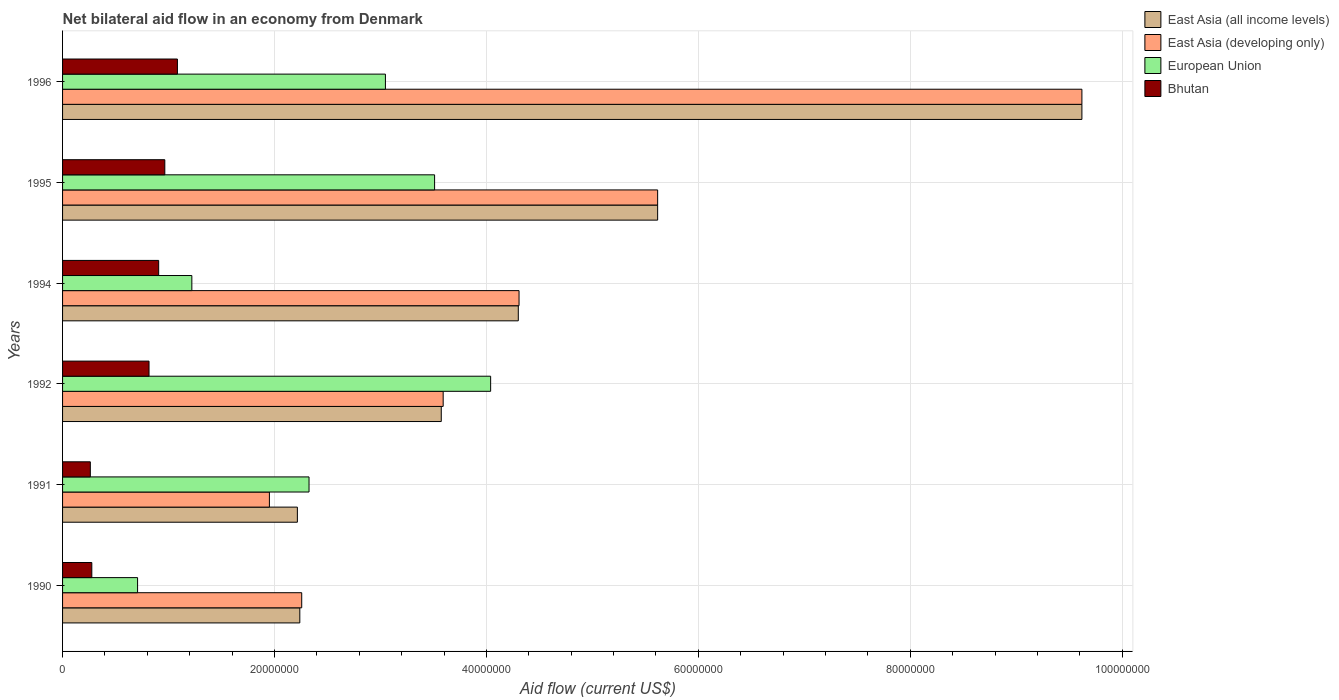How many different coloured bars are there?
Ensure brevity in your answer.  4. Are the number of bars per tick equal to the number of legend labels?
Keep it short and to the point. Yes. Are the number of bars on each tick of the Y-axis equal?
Keep it short and to the point. Yes. How many bars are there on the 2nd tick from the bottom?
Offer a terse response. 4. What is the label of the 6th group of bars from the top?
Keep it short and to the point. 1990. In how many cases, is the number of bars for a given year not equal to the number of legend labels?
Ensure brevity in your answer.  0. What is the net bilateral aid flow in Bhutan in 1992?
Your answer should be very brief. 8.16e+06. Across all years, what is the maximum net bilateral aid flow in Bhutan?
Give a very brief answer. 1.08e+07. Across all years, what is the minimum net bilateral aid flow in East Asia (all income levels)?
Give a very brief answer. 2.22e+07. In which year was the net bilateral aid flow in East Asia (developing only) maximum?
Keep it short and to the point. 1996. In which year was the net bilateral aid flow in East Asia (all income levels) minimum?
Give a very brief answer. 1991. What is the total net bilateral aid flow in European Union in the graph?
Your answer should be compact. 1.49e+08. What is the difference between the net bilateral aid flow in East Asia (all income levels) in 1991 and that in 1992?
Offer a very short reply. -1.36e+07. What is the difference between the net bilateral aid flow in East Asia (developing only) in 1992 and the net bilateral aid flow in European Union in 1995?
Your answer should be very brief. 8.10e+05. What is the average net bilateral aid flow in European Union per year?
Offer a terse response. 2.48e+07. What is the ratio of the net bilateral aid flow in European Union in 1990 to that in 1996?
Ensure brevity in your answer.  0.23. What is the difference between the highest and the second highest net bilateral aid flow in Bhutan?
Make the answer very short. 1.19e+06. What is the difference between the highest and the lowest net bilateral aid flow in Bhutan?
Offer a very short reply. 8.22e+06. In how many years, is the net bilateral aid flow in East Asia (developing only) greater than the average net bilateral aid flow in East Asia (developing only) taken over all years?
Make the answer very short. 2. Is the sum of the net bilateral aid flow in European Union in 1994 and 1995 greater than the maximum net bilateral aid flow in East Asia (all income levels) across all years?
Make the answer very short. No. Is it the case that in every year, the sum of the net bilateral aid flow in European Union and net bilateral aid flow in Bhutan is greater than the sum of net bilateral aid flow in East Asia (all income levels) and net bilateral aid flow in East Asia (developing only)?
Provide a succinct answer. No. What does the 3rd bar from the top in 1992 represents?
Offer a terse response. East Asia (developing only). How many bars are there?
Ensure brevity in your answer.  24. Are all the bars in the graph horizontal?
Make the answer very short. Yes. What is the difference between two consecutive major ticks on the X-axis?
Ensure brevity in your answer.  2.00e+07. What is the title of the graph?
Keep it short and to the point. Net bilateral aid flow in an economy from Denmark. Does "Palau" appear as one of the legend labels in the graph?
Your response must be concise. No. What is the label or title of the Y-axis?
Make the answer very short. Years. What is the Aid flow (current US$) of East Asia (all income levels) in 1990?
Give a very brief answer. 2.24e+07. What is the Aid flow (current US$) in East Asia (developing only) in 1990?
Offer a very short reply. 2.26e+07. What is the Aid flow (current US$) of European Union in 1990?
Make the answer very short. 7.08e+06. What is the Aid flow (current US$) of Bhutan in 1990?
Your answer should be very brief. 2.76e+06. What is the Aid flow (current US$) in East Asia (all income levels) in 1991?
Give a very brief answer. 2.22e+07. What is the Aid flow (current US$) in East Asia (developing only) in 1991?
Give a very brief answer. 1.95e+07. What is the Aid flow (current US$) in European Union in 1991?
Give a very brief answer. 2.33e+07. What is the Aid flow (current US$) in Bhutan in 1991?
Ensure brevity in your answer.  2.62e+06. What is the Aid flow (current US$) in East Asia (all income levels) in 1992?
Offer a terse response. 3.57e+07. What is the Aid flow (current US$) of East Asia (developing only) in 1992?
Your answer should be compact. 3.59e+07. What is the Aid flow (current US$) of European Union in 1992?
Give a very brief answer. 4.04e+07. What is the Aid flow (current US$) of Bhutan in 1992?
Offer a terse response. 8.16e+06. What is the Aid flow (current US$) in East Asia (all income levels) in 1994?
Make the answer very short. 4.30e+07. What is the Aid flow (current US$) of East Asia (developing only) in 1994?
Provide a succinct answer. 4.31e+07. What is the Aid flow (current US$) of European Union in 1994?
Provide a succinct answer. 1.22e+07. What is the Aid flow (current US$) in Bhutan in 1994?
Make the answer very short. 9.07e+06. What is the Aid flow (current US$) in East Asia (all income levels) in 1995?
Keep it short and to the point. 5.62e+07. What is the Aid flow (current US$) in East Asia (developing only) in 1995?
Give a very brief answer. 5.62e+07. What is the Aid flow (current US$) of European Union in 1995?
Your answer should be very brief. 3.51e+07. What is the Aid flow (current US$) of Bhutan in 1995?
Make the answer very short. 9.65e+06. What is the Aid flow (current US$) of East Asia (all income levels) in 1996?
Give a very brief answer. 9.62e+07. What is the Aid flow (current US$) in East Asia (developing only) in 1996?
Provide a short and direct response. 9.62e+07. What is the Aid flow (current US$) of European Union in 1996?
Keep it short and to the point. 3.05e+07. What is the Aid flow (current US$) of Bhutan in 1996?
Keep it short and to the point. 1.08e+07. Across all years, what is the maximum Aid flow (current US$) in East Asia (all income levels)?
Ensure brevity in your answer.  9.62e+07. Across all years, what is the maximum Aid flow (current US$) of East Asia (developing only)?
Offer a terse response. 9.62e+07. Across all years, what is the maximum Aid flow (current US$) of European Union?
Provide a short and direct response. 4.04e+07. Across all years, what is the maximum Aid flow (current US$) of Bhutan?
Make the answer very short. 1.08e+07. Across all years, what is the minimum Aid flow (current US$) in East Asia (all income levels)?
Give a very brief answer. 2.22e+07. Across all years, what is the minimum Aid flow (current US$) in East Asia (developing only)?
Provide a succinct answer. 1.95e+07. Across all years, what is the minimum Aid flow (current US$) in European Union?
Give a very brief answer. 7.08e+06. Across all years, what is the minimum Aid flow (current US$) of Bhutan?
Offer a very short reply. 2.62e+06. What is the total Aid flow (current US$) of East Asia (all income levels) in the graph?
Your response must be concise. 2.76e+08. What is the total Aid flow (current US$) of East Asia (developing only) in the graph?
Keep it short and to the point. 2.73e+08. What is the total Aid flow (current US$) of European Union in the graph?
Offer a terse response. 1.49e+08. What is the total Aid flow (current US$) of Bhutan in the graph?
Your answer should be very brief. 4.31e+07. What is the difference between the Aid flow (current US$) in East Asia (developing only) in 1990 and that in 1991?
Your answer should be very brief. 3.05e+06. What is the difference between the Aid flow (current US$) of European Union in 1990 and that in 1991?
Offer a terse response. -1.62e+07. What is the difference between the Aid flow (current US$) in Bhutan in 1990 and that in 1991?
Provide a short and direct response. 1.40e+05. What is the difference between the Aid flow (current US$) in East Asia (all income levels) in 1990 and that in 1992?
Provide a short and direct response. -1.34e+07. What is the difference between the Aid flow (current US$) of East Asia (developing only) in 1990 and that in 1992?
Your response must be concise. -1.34e+07. What is the difference between the Aid flow (current US$) of European Union in 1990 and that in 1992?
Provide a short and direct response. -3.33e+07. What is the difference between the Aid flow (current US$) in Bhutan in 1990 and that in 1992?
Your answer should be very brief. -5.40e+06. What is the difference between the Aid flow (current US$) in East Asia (all income levels) in 1990 and that in 1994?
Provide a short and direct response. -2.06e+07. What is the difference between the Aid flow (current US$) of East Asia (developing only) in 1990 and that in 1994?
Your response must be concise. -2.05e+07. What is the difference between the Aid flow (current US$) in European Union in 1990 and that in 1994?
Keep it short and to the point. -5.12e+06. What is the difference between the Aid flow (current US$) of Bhutan in 1990 and that in 1994?
Your response must be concise. -6.31e+06. What is the difference between the Aid flow (current US$) in East Asia (all income levels) in 1990 and that in 1995?
Provide a succinct answer. -3.38e+07. What is the difference between the Aid flow (current US$) in East Asia (developing only) in 1990 and that in 1995?
Your answer should be very brief. -3.36e+07. What is the difference between the Aid flow (current US$) in European Union in 1990 and that in 1995?
Provide a succinct answer. -2.80e+07. What is the difference between the Aid flow (current US$) of Bhutan in 1990 and that in 1995?
Your answer should be compact. -6.89e+06. What is the difference between the Aid flow (current US$) of East Asia (all income levels) in 1990 and that in 1996?
Provide a succinct answer. -7.38e+07. What is the difference between the Aid flow (current US$) in East Asia (developing only) in 1990 and that in 1996?
Your answer should be very brief. -7.36e+07. What is the difference between the Aid flow (current US$) of European Union in 1990 and that in 1996?
Your answer should be compact. -2.34e+07. What is the difference between the Aid flow (current US$) of Bhutan in 1990 and that in 1996?
Your response must be concise. -8.08e+06. What is the difference between the Aid flow (current US$) in East Asia (all income levels) in 1991 and that in 1992?
Your response must be concise. -1.36e+07. What is the difference between the Aid flow (current US$) of East Asia (developing only) in 1991 and that in 1992?
Provide a short and direct response. -1.64e+07. What is the difference between the Aid flow (current US$) in European Union in 1991 and that in 1992?
Provide a succinct answer. -1.71e+07. What is the difference between the Aid flow (current US$) of Bhutan in 1991 and that in 1992?
Provide a short and direct response. -5.54e+06. What is the difference between the Aid flow (current US$) in East Asia (all income levels) in 1991 and that in 1994?
Ensure brevity in your answer.  -2.08e+07. What is the difference between the Aid flow (current US$) in East Asia (developing only) in 1991 and that in 1994?
Make the answer very short. -2.36e+07. What is the difference between the Aid flow (current US$) of European Union in 1991 and that in 1994?
Your answer should be compact. 1.11e+07. What is the difference between the Aid flow (current US$) of Bhutan in 1991 and that in 1994?
Provide a succinct answer. -6.45e+06. What is the difference between the Aid flow (current US$) in East Asia (all income levels) in 1991 and that in 1995?
Ensure brevity in your answer.  -3.40e+07. What is the difference between the Aid flow (current US$) of East Asia (developing only) in 1991 and that in 1995?
Offer a terse response. -3.66e+07. What is the difference between the Aid flow (current US$) of European Union in 1991 and that in 1995?
Offer a terse response. -1.18e+07. What is the difference between the Aid flow (current US$) in Bhutan in 1991 and that in 1995?
Your answer should be very brief. -7.03e+06. What is the difference between the Aid flow (current US$) of East Asia (all income levels) in 1991 and that in 1996?
Give a very brief answer. -7.40e+07. What is the difference between the Aid flow (current US$) in East Asia (developing only) in 1991 and that in 1996?
Keep it short and to the point. -7.67e+07. What is the difference between the Aid flow (current US$) of European Union in 1991 and that in 1996?
Give a very brief answer. -7.21e+06. What is the difference between the Aid flow (current US$) of Bhutan in 1991 and that in 1996?
Provide a short and direct response. -8.22e+06. What is the difference between the Aid flow (current US$) in East Asia (all income levels) in 1992 and that in 1994?
Make the answer very short. -7.27e+06. What is the difference between the Aid flow (current US$) of East Asia (developing only) in 1992 and that in 1994?
Provide a short and direct response. -7.16e+06. What is the difference between the Aid flow (current US$) of European Union in 1992 and that in 1994?
Ensure brevity in your answer.  2.82e+07. What is the difference between the Aid flow (current US$) in Bhutan in 1992 and that in 1994?
Your answer should be compact. -9.10e+05. What is the difference between the Aid flow (current US$) of East Asia (all income levels) in 1992 and that in 1995?
Your answer should be very brief. -2.04e+07. What is the difference between the Aid flow (current US$) in East Asia (developing only) in 1992 and that in 1995?
Ensure brevity in your answer.  -2.02e+07. What is the difference between the Aid flow (current US$) of European Union in 1992 and that in 1995?
Keep it short and to the point. 5.29e+06. What is the difference between the Aid flow (current US$) of Bhutan in 1992 and that in 1995?
Offer a very short reply. -1.49e+06. What is the difference between the Aid flow (current US$) of East Asia (all income levels) in 1992 and that in 1996?
Provide a short and direct response. -6.05e+07. What is the difference between the Aid flow (current US$) in East Asia (developing only) in 1992 and that in 1996?
Your answer should be very brief. -6.03e+07. What is the difference between the Aid flow (current US$) in European Union in 1992 and that in 1996?
Provide a succinct answer. 9.93e+06. What is the difference between the Aid flow (current US$) in Bhutan in 1992 and that in 1996?
Your answer should be compact. -2.68e+06. What is the difference between the Aid flow (current US$) in East Asia (all income levels) in 1994 and that in 1995?
Offer a terse response. -1.32e+07. What is the difference between the Aid flow (current US$) in East Asia (developing only) in 1994 and that in 1995?
Offer a terse response. -1.31e+07. What is the difference between the Aid flow (current US$) of European Union in 1994 and that in 1995?
Keep it short and to the point. -2.29e+07. What is the difference between the Aid flow (current US$) in Bhutan in 1994 and that in 1995?
Your answer should be compact. -5.80e+05. What is the difference between the Aid flow (current US$) of East Asia (all income levels) in 1994 and that in 1996?
Your response must be concise. -5.32e+07. What is the difference between the Aid flow (current US$) in East Asia (developing only) in 1994 and that in 1996?
Keep it short and to the point. -5.31e+07. What is the difference between the Aid flow (current US$) of European Union in 1994 and that in 1996?
Ensure brevity in your answer.  -1.83e+07. What is the difference between the Aid flow (current US$) of Bhutan in 1994 and that in 1996?
Your answer should be compact. -1.77e+06. What is the difference between the Aid flow (current US$) of East Asia (all income levels) in 1995 and that in 1996?
Offer a terse response. -4.00e+07. What is the difference between the Aid flow (current US$) in East Asia (developing only) in 1995 and that in 1996?
Make the answer very short. -4.00e+07. What is the difference between the Aid flow (current US$) in European Union in 1995 and that in 1996?
Ensure brevity in your answer.  4.64e+06. What is the difference between the Aid flow (current US$) in Bhutan in 1995 and that in 1996?
Provide a succinct answer. -1.19e+06. What is the difference between the Aid flow (current US$) in East Asia (all income levels) in 1990 and the Aid flow (current US$) in East Asia (developing only) in 1991?
Your answer should be compact. 2.87e+06. What is the difference between the Aid flow (current US$) of East Asia (all income levels) in 1990 and the Aid flow (current US$) of European Union in 1991?
Keep it short and to the point. -8.70e+05. What is the difference between the Aid flow (current US$) in East Asia (all income levels) in 1990 and the Aid flow (current US$) in Bhutan in 1991?
Give a very brief answer. 1.98e+07. What is the difference between the Aid flow (current US$) of East Asia (developing only) in 1990 and the Aid flow (current US$) of European Union in 1991?
Your answer should be very brief. -6.90e+05. What is the difference between the Aid flow (current US$) in East Asia (developing only) in 1990 and the Aid flow (current US$) in Bhutan in 1991?
Your answer should be very brief. 2.00e+07. What is the difference between the Aid flow (current US$) of European Union in 1990 and the Aid flow (current US$) of Bhutan in 1991?
Your answer should be compact. 4.46e+06. What is the difference between the Aid flow (current US$) of East Asia (all income levels) in 1990 and the Aid flow (current US$) of East Asia (developing only) in 1992?
Keep it short and to the point. -1.35e+07. What is the difference between the Aid flow (current US$) in East Asia (all income levels) in 1990 and the Aid flow (current US$) in European Union in 1992?
Make the answer very short. -1.80e+07. What is the difference between the Aid flow (current US$) in East Asia (all income levels) in 1990 and the Aid flow (current US$) in Bhutan in 1992?
Give a very brief answer. 1.42e+07. What is the difference between the Aid flow (current US$) of East Asia (developing only) in 1990 and the Aid flow (current US$) of European Union in 1992?
Offer a very short reply. -1.78e+07. What is the difference between the Aid flow (current US$) of East Asia (developing only) in 1990 and the Aid flow (current US$) of Bhutan in 1992?
Offer a terse response. 1.44e+07. What is the difference between the Aid flow (current US$) in European Union in 1990 and the Aid flow (current US$) in Bhutan in 1992?
Make the answer very short. -1.08e+06. What is the difference between the Aid flow (current US$) of East Asia (all income levels) in 1990 and the Aid flow (current US$) of East Asia (developing only) in 1994?
Your answer should be compact. -2.07e+07. What is the difference between the Aid flow (current US$) of East Asia (all income levels) in 1990 and the Aid flow (current US$) of European Union in 1994?
Make the answer very short. 1.02e+07. What is the difference between the Aid flow (current US$) in East Asia (all income levels) in 1990 and the Aid flow (current US$) in Bhutan in 1994?
Offer a very short reply. 1.33e+07. What is the difference between the Aid flow (current US$) in East Asia (developing only) in 1990 and the Aid flow (current US$) in European Union in 1994?
Your answer should be compact. 1.04e+07. What is the difference between the Aid flow (current US$) of East Asia (developing only) in 1990 and the Aid flow (current US$) of Bhutan in 1994?
Your answer should be very brief. 1.35e+07. What is the difference between the Aid flow (current US$) of European Union in 1990 and the Aid flow (current US$) of Bhutan in 1994?
Offer a terse response. -1.99e+06. What is the difference between the Aid flow (current US$) in East Asia (all income levels) in 1990 and the Aid flow (current US$) in East Asia (developing only) in 1995?
Offer a very short reply. -3.38e+07. What is the difference between the Aid flow (current US$) of East Asia (all income levels) in 1990 and the Aid flow (current US$) of European Union in 1995?
Provide a succinct answer. -1.27e+07. What is the difference between the Aid flow (current US$) in East Asia (all income levels) in 1990 and the Aid flow (current US$) in Bhutan in 1995?
Make the answer very short. 1.27e+07. What is the difference between the Aid flow (current US$) in East Asia (developing only) in 1990 and the Aid flow (current US$) in European Union in 1995?
Keep it short and to the point. -1.25e+07. What is the difference between the Aid flow (current US$) in East Asia (developing only) in 1990 and the Aid flow (current US$) in Bhutan in 1995?
Keep it short and to the point. 1.29e+07. What is the difference between the Aid flow (current US$) in European Union in 1990 and the Aid flow (current US$) in Bhutan in 1995?
Ensure brevity in your answer.  -2.57e+06. What is the difference between the Aid flow (current US$) in East Asia (all income levels) in 1990 and the Aid flow (current US$) in East Asia (developing only) in 1996?
Offer a very short reply. -7.38e+07. What is the difference between the Aid flow (current US$) of East Asia (all income levels) in 1990 and the Aid flow (current US$) of European Union in 1996?
Ensure brevity in your answer.  -8.08e+06. What is the difference between the Aid flow (current US$) in East Asia (all income levels) in 1990 and the Aid flow (current US$) in Bhutan in 1996?
Provide a succinct answer. 1.16e+07. What is the difference between the Aid flow (current US$) in East Asia (developing only) in 1990 and the Aid flow (current US$) in European Union in 1996?
Make the answer very short. -7.90e+06. What is the difference between the Aid flow (current US$) of East Asia (developing only) in 1990 and the Aid flow (current US$) of Bhutan in 1996?
Provide a succinct answer. 1.17e+07. What is the difference between the Aid flow (current US$) of European Union in 1990 and the Aid flow (current US$) of Bhutan in 1996?
Ensure brevity in your answer.  -3.76e+06. What is the difference between the Aid flow (current US$) in East Asia (all income levels) in 1991 and the Aid flow (current US$) in East Asia (developing only) in 1992?
Offer a terse response. -1.38e+07. What is the difference between the Aid flow (current US$) in East Asia (all income levels) in 1991 and the Aid flow (current US$) in European Union in 1992?
Offer a very short reply. -1.82e+07. What is the difference between the Aid flow (current US$) in East Asia (all income levels) in 1991 and the Aid flow (current US$) in Bhutan in 1992?
Offer a terse response. 1.40e+07. What is the difference between the Aid flow (current US$) of East Asia (developing only) in 1991 and the Aid flow (current US$) of European Union in 1992?
Your response must be concise. -2.09e+07. What is the difference between the Aid flow (current US$) in East Asia (developing only) in 1991 and the Aid flow (current US$) in Bhutan in 1992?
Keep it short and to the point. 1.14e+07. What is the difference between the Aid flow (current US$) of European Union in 1991 and the Aid flow (current US$) of Bhutan in 1992?
Offer a terse response. 1.51e+07. What is the difference between the Aid flow (current US$) in East Asia (all income levels) in 1991 and the Aid flow (current US$) in East Asia (developing only) in 1994?
Your response must be concise. -2.09e+07. What is the difference between the Aid flow (current US$) in East Asia (all income levels) in 1991 and the Aid flow (current US$) in European Union in 1994?
Your answer should be compact. 9.96e+06. What is the difference between the Aid flow (current US$) in East Asia (all income levels) in 1991 and the Aid flow (current US$) in Bhutan in 1994?
Your answer should be very brief. 1.31e+07. What is the difference between the Aid flow (current US$) of East Asia (developing only) in 1991 and the Aid flow (current US$) of European Union in 1994?
Provide a succinct answer. 7.32e+06. What is the difference between the Aid flow (current US$) in East Asia (developing only) in 1991 and the Aid flow (current US$) in Bhutan in 1994?
Your answer should be very brief. 1.04e+07. What is the difference between the Aid flow (current US$) of European Union in 1991 and the Aid flow (current US$) of Bhutan in 1994?
Your answer should be very brief. 1.42e+07. What is the difference between the Aid flow (current US$) in East Asia (all income levels) in 1991 and the Aid flow (current US$) in East Asia (developing only) in 1995?
Give a very brief answer. -3.40e+07. What is the difference between the Aid flow (current US$) in East Asia (all income levels) in 1991 and the Aid flow (current US$) in European Union in 1995?
Provide a succinct answer. -1.30e+07. What is the difference between the Aid flow (current US$) of East Asia (all income levels) in 1991 and the Aid flow (current US$) of Bhutan in 1995?
Keep it short and to the point. 1.25e+07. What is the difference between the Aid flow (current US$) of East Asia (developing only) in 1991 and the Aid flow (current US$) of European Union in 1995?
Your answer should be compact. -1.56e+07. What is the difference between the Aid flow (current US$) in East Asia (developing only) in 1991 and the Aid flow (current US$) in Bhutan in 1995?
Make the answer very short. 9.87e+06. What is the difference between the Aid flow (current US$) of European Union in 1991 and the Aid flow (current US$) of Bhutan in 1995?
Your answer should be very brief. 1.36e+07. What is the difference between the Aid flow (current US$) of East Asia (all income levels) in 1991 and the Aid flow (current US$) of East Asia (developing only) in 1996?
Offer a very short reply. -7.40e+07. What is the difference between the Aid flow (current US$) in East Asia (all income levels) in 1991 and the Aid flow (current US$) in European Union in 1996?
Ensure brevity in your answer.  -8.31e+06. What is the difference between the Aid flow (current US$) of East Asia (all income levels) in 1991 and the Aid flow (current US$) of Bhutan in 1996?
Your answer should be compact. 1.13e+07. What is the difference between the Aid flow (current US$) of East Asia (developing only) in 1991 and the Aid flow (current US$) of European Union in 1996?
Give a very brief answer. -1.10e+07. What is the difference between the Aid flow (current US$) of East Asia (developing only) in 1991 and the Aid flow (current US$) of Bhutan in 1996?
Offer a terse response. 8.68e+06. What is the difference between the Aid flow (current US$) of European Union in 1991 and the Aid flow (current US$) of Bhutan in 1996?
Ensure brevity in your answer.  1.24e+07. What is the difference between the Aid flow (current US$) in East Asia (all income levels) in 1992 and the Aid flow (current US$) in East Asia (developing only) in 1994?
Your answer should be compact. -7.34e+06. What is the difference between the Aid flow (current US$) in East Asia (all income levels) in 1992 and the Aid flow (current US$) in European Union in 1994?
Ensure brevity in your answer.  2.35e+07. What is the difference between the Aid flow (current US$) of East Asia (all income levels) in 1992 and the Aid flow (current US$) of Bhutan in 1994?
Provide a succinct answer. 2.67e+07. What is the difference between the Aid flow (current US$) in East Asia (developing only) in 1992 and the Aid flow (current US$) in European Union in 1994?
Your answer should be compact. 2.37e+07. What is the difference between the Aid flow (current US$) in East Asia (developing only) in 1992 and the Aid flow (current US$) in Bhutan in 1994?
Your answer should be compact. 2.68e+07. What is the difference between the Aid flow (current US$) of European Union in 1992 and the Aid flow (current US$) of Bhutan in 1994?
Ensure brevity in your answer.  3.13e+07. What is the difference between the Aid flow (current US$) in East Asia (all income levels) in 1992 and the Aid flow (current US$) in East Asia (developing only) in 1995?
Your answer should be very brief. -2.04e+07. What is the difference between the Aid flow (current US$) of East Asia (all income levels) in 1992 and the Aid flow (current US$) of European Union in 1995?
Provide a short and direct response. 6.30e+05. What is the difference between the Aid flow (current US$) in East Asia (all income levels) in 1992 and the Aid flow (current US$) in Bhutan in 1995?
Provide a short and direct response. 2.61e+07. What is the difference between the Aid flow (current US$) in East Asia (developing only) in 1992 and the Aid flow (current US$) in European Union in 1995?
Your answer should be compact. 8.10e+05. What is the difference between the Aid flow (current US$) in East Asia (developing only) in 1992 and the Aid flow (current US$) in Bhutan in 1995?
Ensure brevity in your answer.  2.63e+07. What is the difference between the Aid flow (current US$) in European Union in 1992 and the Aid flow (current US$) in Bhutan in 1995?
Your response must be concise. 3.08e+07. What is the difference between the Aid flow (current US$) of East Asia (all income levels) in 1992 and the Aid flow (current US$) of East Asia (developing only) in 1996?
Offer a terse response. -6.05e+07. What is the difference between the Aid flow (current US$) of East Asia (all income levels) in 1992 and the Aid flow (current US$) of European Union in 1996?
Provide a succinct answer. 5.27e+06. What is the difference between the Aid flow (current US$) in East Asia (all income levels) in 1992 and the Aid flow (current US$) in Bhutan in 1996?
Offer a terse response. 2.49e+07. What is the difference between the Aid flow (current US$) in East Asia (developing only) in 1992 and the Aid flow (current US$) in European Union in 1996?
Your answer should be compact. 5.45e+06. What is the difference between the Aid flow (current US$) in East Asia (developing only) in 1992 and the Aid flow (current US$) in Bhutan in 1996?
Make the answer very short. 2.51e+07. What is the difference between the Aid flow (current US$) of European Union in 1992 and the Aid flow (current US$) of Bhutan in 1996?
Your answer should be very brief. 2.96e+07. What is the difference between the Aid flow (current US$) of East Asia (all income levels) in 1994 and the Aid flow (current US$) of East Asia (developing only) in 1995?
Your answer should be very brief. -1.32e+07. What is the difference between the Aid flow (current US$) in East Asia (all income levels) in 1994 and the Aid flow (current US$) in European Union in 1995?
Your answer should be very brief. 7.90e+06. What is the difference between the Aid flow (current US$) of East Asia (all income levels) in 1994 and the Aid flow (current US$) of Bhutan in 1995?
Offer a terse response. 3.34e+07. What is the difference between the Aid flow (current US$) of East Asia (developing only) in 1994 and the Aid flow (current US$) of European Union in 1995?
Offer a terse response. 7.97e+06. What is the difference between the Aid flow (current US$) in East Asia (developing only) in 1994 and the Aid flow (current US$) in Bhutan in 1995?
Make the answer very short. 3.34e+07. What is the difference between the Aid flow (current US$) in European Union in 1994 and the Aid flow (current US$) in Bhutan in 1995?
Your response must be concise. 2.55e+06. What is the difference between the Aid flow (current US$) of East Asia (all income levels) in 1994 and the Aid flow (current US$) of East Asia (developing only) in 1996?
Keep it short and to the point. -5.32e+07. What is the difference between the Aid flow (current US$) of East Asia (all income levels) in 1994 and the Aid flow (current US$) of European Union in 1996?
Offer a very short reply. 1.25e+07. What is the difference between the Aid flow (current US$) of East Asia (all income levels) in 1994 and the Aid flow (current US$) of Bhutan in 1996?
Ensure brevity in your answer.  3.22e+07. What is the difference between the Aid flow (current US$) in East Asia (developing only) in 1994 and the Aid flow (current US$) in European Union in 1996?
Provide a succinct answer. 1.26e+07. What is the difference between the Aid flow (current US$) in East Asia (developing only) in 1994 and the Aid flow (current US$) in Bhutan in 1996?
Ensure brevity in your answer.  3.22e+07. What is the difference between the Aid flow (current US$) of European Union in 1994 and the Aid flow (current US$) of Bhutan in 1996?
Give a very brief answer. 1.36e+06. What is the difference between the Aid flow (current US$) of East Asia (all income levels) in 1995 and the Aid flow (current US$) of East Asia (developing only) in 1996?
Ensure brevity in your answer.  -4.00e+07. What is the difference between the Aid flow (current US$) of East Asia (all income levels) in 1995 and the Aid flow (current US$) of European Union in 1996?
Your response must be concise. 2.57e+07. What is the difference between the Aid flow (current US$) in East Asia (all income levels) in 1995 and the Aid flow (current US$) in Bhutan in 1996?
Ensure brevity in your answer.  4.53e+07. What is the difference between the Aid flow (current US$) in East Asia (developing only) in 1995 and the Aid flow (current US$) in European Union in 1996?
Make the answer very short. 2.57e+07. What is the difference between the Aid flow (current US$) of East Asia (developing only) in 1995 and the Aid flow (current US$) of Bhutan in 1996?
Your answer should be compact. 4.53e+07. What is the difference between the Aid flow (current US$) in European Union in 1995 and the Aid flow (current US$) in Bhutan in 1996?
Ensure brevity in your answer.  2.43e+07. What is the average Aid flow (current US$) in East Asia (all income levels) per year?
Make the answer very short. 4.59e+07. What is the average Aid flow (current US$) of East Asia (developing only) per year?
Your response must be concise. 4.56e+07. What is the average Aid flow (current US$) of European Union per year?
Offer a terse response. 2.48e+07. What is the average Aid flow (current US$) of Bhutan per year?
Keep it short and to the point. 7.18e+06. In the year 1990, what is the difference between the Aid flow (current US$) in East Asia (all income levels) and Aid flow (current US$) in European Union?
Your answer should be compact. 1.53e+07. In the year 1990, what is the difference between the Aid flow (current US$) in East Asia (all income levels) and Aid flow (current US$) in Bhutan?
Offer a very short reply. 1.96e+07. In the year 1990, what is the difference between the Aid flow (current US$) in East Asia (developing only) and Aid flow (current US$) in European Union?
Offer a very short reply. 1.55e+07. In the year 1990, what is the difference between the Aid flow (current US$) in East Asia (developing only) and Aid flow (current US$) in Bhutan?
Offer a terse response. 1.98e+07. In the year 1990, what is the difference between the Aid flow (current US$) in European Union and Aid flow (current US$) in Bhutan?
Your answer should be very brief. 4.32e+06. In the year 1991, what is the difference between the Aid flow (current US$) of East Asia (all income levels) and Aid flow (current US$) of East Asia (developing only)?
Your answer should be very brief. 2.64e+06. In the year 1991, what is the difference between the Aid flow (current US$) in East Asia (all income levels) and Aid flow (current US$) in European Union?
Offer a very short reply. -1.10e+06. In the year 1991, what is the difference between the Aid flow (current US$) of East Asia (all income levels) and Aid flow (current US$) of Bhutan?
Provide a succinct answer. 1.95e+07. In the year 1991, what is the difference between the Aid flow (current US$) in East Asia (developing only) and Aid flow (current US$) in European Union?
Offer a terse response. -3.74e+06. In the year 1991, what is the difference between the Aid flow (current US$) in East Asia (developing only) and Aid flow (current US$) in Bhutan?
Provide a succinct answer. 1.69e+07. In the year 1991, what is the difference between the Aid flow (current US$) in European Union and Aid flow (current US$) in Bhutan?
Your answer should be very brief. 2.06e+07. In the year 1992, what is the difference between the Aid flow (current US$) of East Asia (all income levels) and Aid flow (current US$) of European Union?
Offer a very short reply. -4.66e+06. In the year 1992, what is the difference between the Aid flow (current US$) in East Asia (all income levels) and Aid flow (current US$) in Bhutan?
Make the answer very short. 2.76e+07. In the year 1992, what is the difference between the Aid flow (current US$) of East Asia (developing only) and Aid flow (current US$) of European Union?
Keep it short and to the point. -4.48e+06. In the year 1992, what is the difference between the Aid flow (current US$) of East Asia (developing only) and Aid flow (current US$) of Bhutan?
Your answer should be very brief. 2.78e+07. In the year 1992, what is the difference between the Aid flow (current US$) in European Union and Aid flow (current US$) in Bhutan?
Provide a succinct answer. 3.22e+07. In the year 1994, what is the difference between the Aid flow (current US$) in East Asia (all income levels) and Aid flow (current US$) in East Asia (developing only)?
Ensure brevity in your answer.  -7.00e+04. In the year 1994, what is the difference between the Aid flow (current US$) of East Asia (all income levels) and Aid flow (current US$) of European Union?
Make the answer very short. 3.08e+07. In the year 1994, what is the difference between the Aid flow (current US$) in East Asia (all income levels) and Aid flow (current US$) in Bhutan?
Make the answer very short. 3.39e+07. In the year 1994, what is the difference between the Aid flow (current US$) in East Asia (developing only) and Aid flow (current US$) in European Union?
Your answer should be compact. 3.09e+07. In the year 1994, what is the difference between the Aid flow (current US$) of East Asia (developing only) and Aid flow (current US$) of Bhutan?
Offer a terse response. 3.40e+07. In the year 1994, what is the difference between the Aid flow (current US$) in European Union and Aid flow (current US$) in Bhutan?
Offer a terse response. 3.13e+06. In the year 1995, what is the difference between the Aid flow (current US$) in East Asia (all income levels) and Aid flow (current US$) in European Union?
Your response must be concise. 2.10e+07. In the year 1995, what is the difference between the Aid flow (current US$) of East Asia (all income levels) and Aid flow (current US$) of Bhutan?
Your answer should be compact. 4.65e+07. In the year 1995, what is the difference between the Aid flow (current US$) of East Asia (developing only) and Aid flow (current US$) of European Union?
Your answer should be very brief. 2.10e+07. In the year 1995, what is the difference between the Aid flow (current US$) of East Asia (developing only) and Aid flow (current US$) of Bhutan?
Provide a succinct answer. 4.65e+07. In the year 1995, what is the difference between the Aid flow (current US$) in European Union and Aid flow (current US$) in Bhutan?
Provide a short and direct response. 2.55e+07. In the year 1996, what is the difference between the Aid flow (current US$) of East Asia (all income levels) and Aid flow (current US$) of East Asia (developing only)?
Your answer should be compact. 0. In the year 1996, what is the difference between the Aid flow (current US$) in East Asia (all income levels) and Aid flow (current US$) in European Union?
Give a very brief answer. 6.57e+07. In the year 1996, what is the difference between the Aid flow (current US$) of East Asia (all income levels) and Aid flow (current US$) of Bhutan?
Offer a terse response. 8.54e+07. In the year 1996, what is the difference between the Aid flow (current US$) of East Asia (developing only) and Aid flow (current US$) of European Union?
Provide a succinct answer. 6.57e+07. In the year 1996, what is the difference between the Aid flow (current US$) of East Asia (developing only) and Aid flow (current US$) of Bhutan?
Your response must be concise. 8.54e+07. In the year 1996, what is the difference between the Aid flow (current US$) in European Union and Aid flow (current US$) in Bhutan?
Your answer should be very brief. 1.96e+07. What is the ratio of the Aid flow (current US$) in East Asia (all income levels) in 1990 to that in 1991?
Provide a succinct answer. 1.01. What is the ratio of the Aid flow (current US$) in East Asia (developing only) in 1990 to that in 1991?
Provide a succinct answer. 1.16. What is the ratio of the Aid flow (current US$) of European Union in 1990 to that in 1991?
Your answer should be very brief. 0.3. What is the ratio of the Aid flow (current US$) in Bhutan in 1990 to that in 1991?
Ensure brevity in your answer.  1.05. What is the ratio of the Aid flow (current US$) of East Asia (all income levels) in 1990 to that in 1992?
Offer a very short reply. 0.63. What is the ratio of the Aid flow (current US$) of East Asia (developing only) in 1990 to that in 1992?
Offer a very short reply. 0.63. What is the ratio of the Aid flow (current US$) of European Union in 1990 to that in 1992?
Your answer should be very brief. 0.18. What is the ratio of the Aid flow (current US$) of Bhutan in 1990 to that in 1992?
Make the answer very short. 0.34. What is the ratio of the Aid flow (current US$) of East Asia (all income levels) in 1990 to that in 1994?
Offer a terse response. 0.52. What is the ratio of the Aid flow (current US$) of East Asia (developing only) in 1990 to that in 1994?
Keep it short and to the point. 0.52. What is the ratio of the Aid flow (current US$) in European Union in 1990 to that in 1994?
Your response must be concise. 0.58. What is the ratio of the Aid flow (current US$) of Bhutan in 1990 to that in 1994?
Provide a short and direct response. 0.3. What is the ratio of the Aid flow (current US$) in East Asia (all income levels) in 1990 to that in 1995?
Offer a terse response. 0.4. What is the ratio of the Aid flow (current US$) in East Asia (developing only) in 1990 to that in 1995?
Provide a short and direct response. 0.4. What is the ratio of the Aid flow (current US$) of European Union in 1990 to that in 1995?
Provide a succinct answer. 0.2. What is the ratio of the Aid flow (current US$) of Bhutan in 1990 to that in 1995?
Provide a succinct answer. 0.29. What is the ratio of the Aid flow (current US$) in East Asia (all income levels) in 1990 to that in 1996?
Offer a terse response. 0.23. What is the ratio of the Aid flow (current US$) of East Asia (developing only) in 1990 to that in 1996?
Give a very brief answer. 0.23. What is the ratio of the Aid flow (current US$) in European Union in 1990 to that in 1996?
Offer a very short reply. 0.23. What is the ratio of the Aid flow (current US$) in Bhutan in 1990 to that in 1996?
Your response must be concise. 0.25. What is the ratio of the Aid flow (current US$) in East Asia (all income levels) in 1991 to that in 1992?
Your response must be concise. 0.62. What is the ratio of the Aid flow (current US$) of East Asia (developing only) in 1991 to that in 1992?
Make the answer very short. 0.54. What is the ratio of the Aid flow (current US$) in European Union in 1991 to that in 1992?
Offer a terse response. 0.58. What is the ratio of the Aid flow (current US$) of Bhutan in 1991 to that in 1992?
Your response must be concise. 0.32. What is the ratio of the Aid flow (current US$) of East Asia (all income levels) in 1991 to that in 1994?
Your response must be concise. 0.52. What is the ratio of the Aid flow (current US$) of East Asia (developing only) in 1991 to that in 1994?
Your answer should be compact. 0.45. What is the ratio of the Aid flow (current US$) of European Union in 1991 to that in 1994?
Give a very brief answer. 1.91. What is the ratio of the Aid flow (current US$) in Bhutan in 1991 to that in 1994?
Your response must be concise. 0.29. What is the ratio of the Aid flow (current US$) of East Asia (all income levels) in 1991 to that in 1995?
Your answer should be compact. 0.39. What is the ratio of the Aid flow (current US$) in East Asia (developing only) in 1991 to that in 1995?
Offer a very short reply. 0.35. What is the ratio of the Aid flow (current US$) of European Union in 1991 to that in 1995?
Ensure brevity in your answer.  0.66. What is the ratio of the Aid flow (current US$) in Bhutan in 1991 to that in 1995?
Ensure brevity in your answer.  0.27. What is the ratio of the Aid flow (current US$) in East Asia (all income levels) in 1991 to that in 1996?
Offer a very short reply. 0.23. What is the ratio of the Aid flow (current US$) in East Asia (developing only) in 1991 to that in 1996?
Give a very brief answer. 0.2. What is the ratio of the Aid flow (current US$) in European Union in 1991 to that in 1996?
Offer a terse response. 0.76. What is the ratio of the Aid flow (current US$) of Bhutan in 1991 to that in 1996?
Keep it short and to the point. 0.24. What is the ratio of the Aid flow (current US$) in East Asia (all income levels) in 1992 to that in 1994?
Make the answer very short. 0.83. What is the ratio of the Aid flow (current US$) in East Asia (developing only) in 1992 to that in 1994?
Keep it short and to the point. 0.83. What is the ratio of the Aid flow (current US$) in European Union in 1992 to that in 1994?
Keep it short and to the point. 3.31. What is the ratio of the Aid flow (current US$) of Bhutan in 1992 to that in 1994?
Provide a succinct answer. 0.9. What is the ratio of the Aid flow (current US$) in East Asia (all income levels) in 1992 to that in 1995?
Your answer should be compact. 0.64. What is the ratio of the Aid flow (current US$) of East Asia (developing only) in 1992 to that in 1995?
Keep it short and to the point. 0.64. What is the ratio of the Aid flow (current US$) in European Union in 1992 to that in 1995?
Your answer should be compact. 1.15. What is the ratio of the Aid flow (current US$) in Bhutan in 1992 to that in 1995?
Make the answer very short. 0.85. What is the ratio of the Aid flow (current US$) in East Asia (all income levels) in 1992 to that in 1996?
Provide a short and direct response. 0.37. What is the ratio of the Aid flow (current US$) of East Asia (developing only) in 1992 to that in 1996?
Your answer should be compact. 0.37. What is the ratio of the Aid flow (current US$) in European Union in 1992 to that in 1996?
Offer a terse response. 1.33. What is the ratio of the Aid flow (current US$) in Bhutan in 1992 to that in 1996?
Offer a terse response. 0.75. What is the ratio of the Aid flow (current US$) of East Asia (all income levels) in 1994 to that in 1995?
Your response must be concise. 0.77. What is the ratio of the Aid flow (current US$) of East Asia (developing only) in 1994 to that in 1995?
Offer a terse response. 0.77. What is the ratio of the Aid flow (current US$) in European Union in 1994 to that in 1995?
Ensure brevity in your answer.  0.35. What is the ratio of the Aid flow (current US$) of Bhutan in 1994 to that in 1995?
Your response must be concise. 0.94. What is the ratio of the Aid flow (current US$) of East Asia (all income levels) in 1994 to that in 1996?
Your response must be concise. 0.45. What is the ratio of the Aid flow (current US$) of East Asia (developing only) in 1994 to that in 1996?
Make the answer very short. 0.45. What is the ratio of the Aid flow (current US$) of European Union in 1994 to that in 1996?
Make the answer very short. 0.4. What is the ratio of the Aid flow (current US$) in Bhutan in 1994 to that in 1996?
Ensure brevity in your answer.  0.84. What is the ratio of the Aid flow (current US$) of East Asia (all income levels) in 1995 to that in 1996?
Your answer should be compact. 0.58. What is the ratio of the Aid flow (current US$) in East Asia (developing only) in 1995 to that in 1996?
Offer a terse response. 0.58. What is the ratio of the Aid flow (current US$) of European Union in 1995 to that in 1996?
Give a very brief answer. 1.15. What is the ratio of the Aid flow (current US$) in Bhutan in 1995 to that in 1996?
Your response must be concise. 0.89. What is the difference between the highest and the second highest Aid flow (current US$) in East Asia (all income levels)?
Give a very brief answer. 4.00e+07. What is the difference between the highest and the second highest Aid flow (current US$) of East Asia (developing only)?
Your answer should be very brief. 4.00e+07. What is the difference between the highest and the second highest Aid flow (current US$) in European Union?
Your answer should be compact. 5.29e+06. What is the difference between the highest and the second highest Aid flow (current US$) in Bhutan?
Provide a succinct answer. 1.19e+06. What is the difference between the highest and the lowest Aid flow (current US$) in East Asia (all income levels)?
Keep it short and to the point. 7.40e+07. What is the difference between the highest and the lowest Aid flow (current US$) in East Asia (developing only)?
Provide a succinct answer. 7.67e+07. What is the difference between the highest and the lowest Aid flow (current US$) in European Union?
Give a very brief answer. 3.33e+07. What is the difference between the highest and the lowest Aid flow (current US$) of Bhutan?
Make the answer very short. 8.22e+06. 